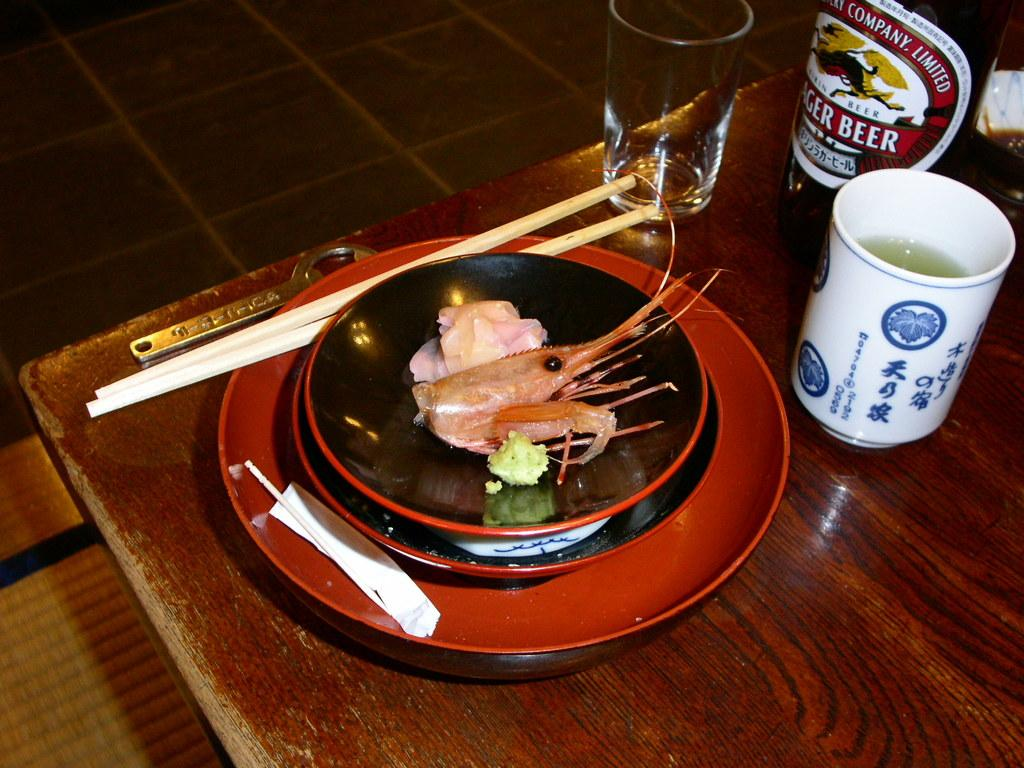What type of furniture is in the image? There is a table in the image. What items are on the table? Plates, chopsticks, glasses, and a bottle are on the table. What food items can be seen on the plates? Prawns are on the plates. Where is the table located? The table is on the floor. How many shoes are visible on the table in the image? There are no shoes visible on the table in the image. 